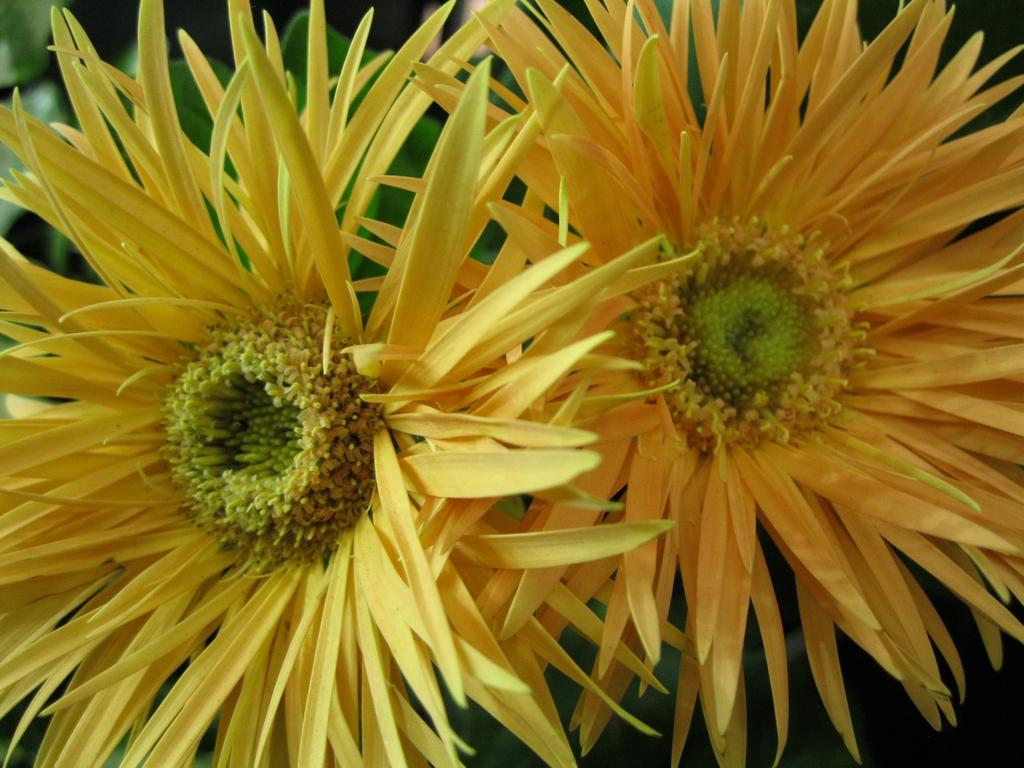Where was the image taken? The image was taken outdoors. What can be seen in the background of the image? There is a plant with green leaves in the background. What are the main subjects in the middle of the image? There are two sunflowers in the middle of the image. What color are the sunflowers? The sunflowers are yellow in color. Can you see a snail crawling on the sunflowers in the image? There is no snail present on the sunflowers in the image. What type of vessel is being used to water the sunflowers in the image? There is no vessel visible in the image, as it only shows the sunflowers and the plant with green leaves in the background. 